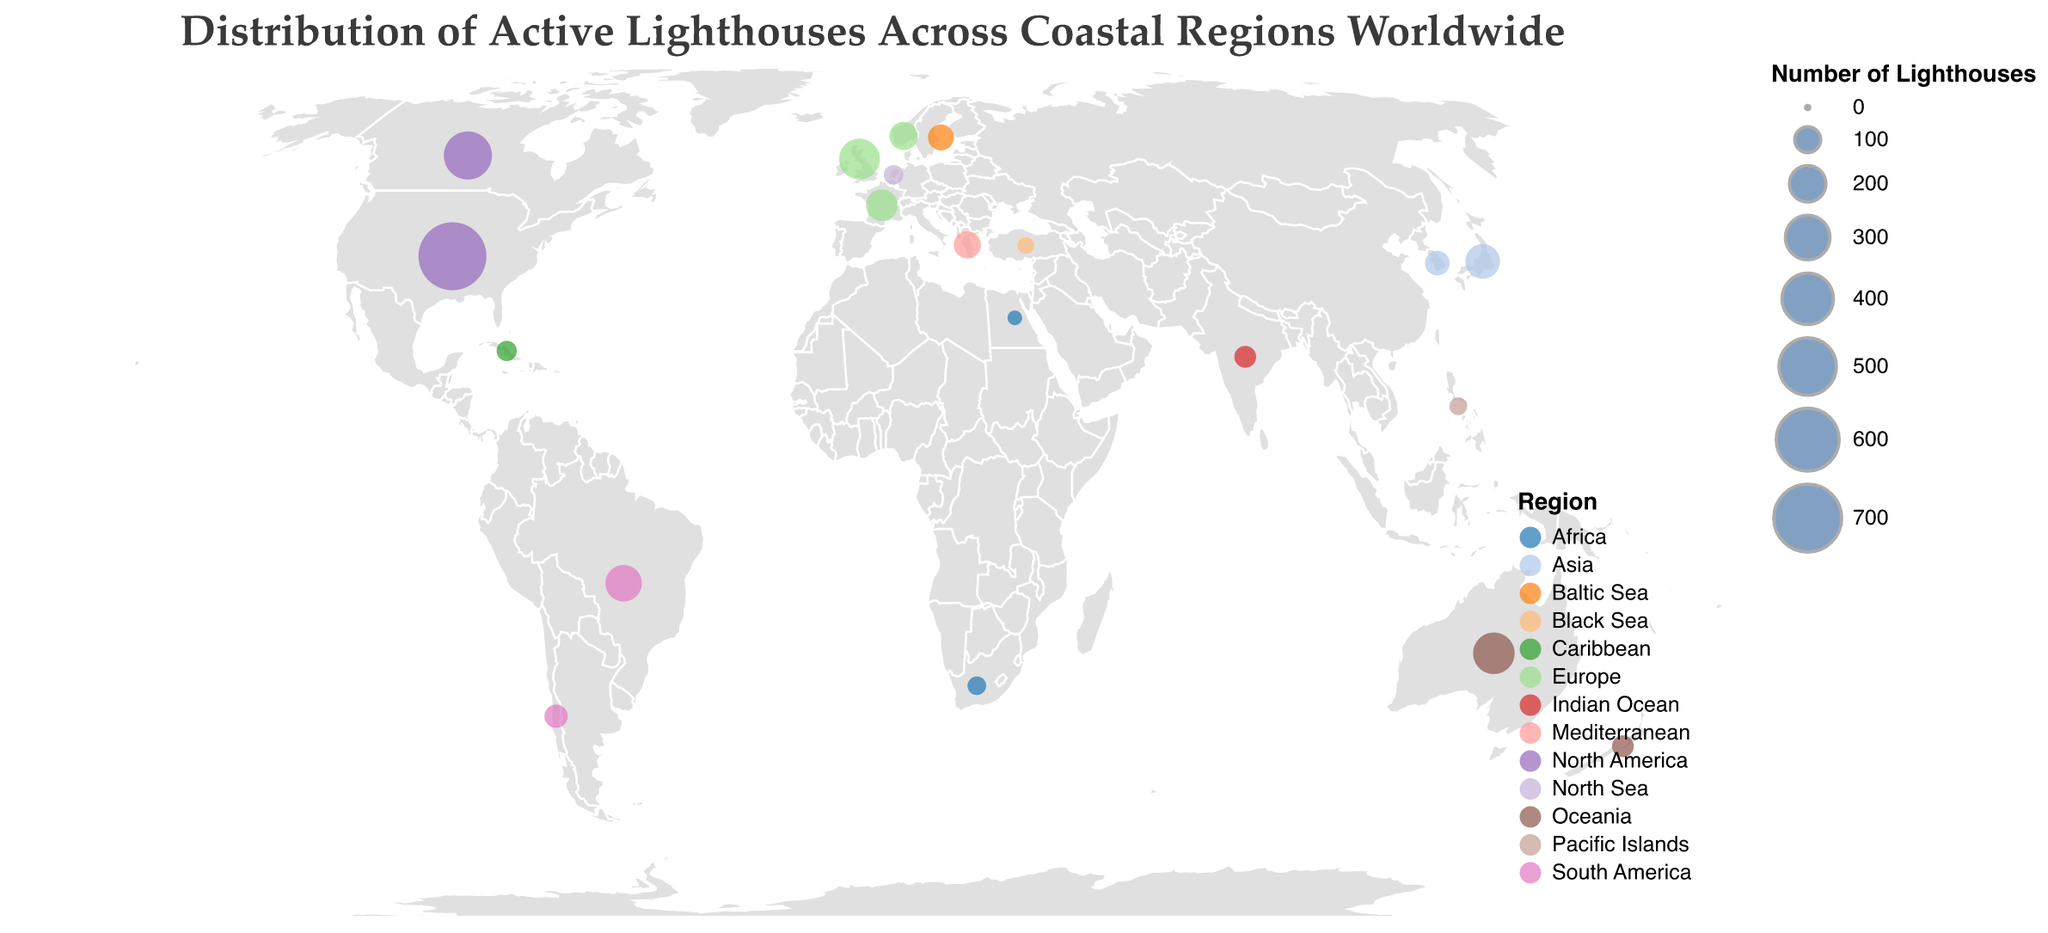What does the title of the figure convey? The title of the figure is "Distribution of Active Lighthouses Across Coastal Regions Worldwide." This indicates that the plot shows the geographical spread or density of active lighthouses in various coastal regions around the world.
Answer: Distribution of Active Lighthouses Across Coastal Regions Worldwide Which region is represented by the most colorful legend in the plot? The legend shows different colors for each region. The region with the most number of lighthouses, represented by the largest circles and most prominently shown, is North America.
Answer: North America How many lighthouses are there in total across Europe? To find the total number of lighthouses in Europe, sum the number of lighthouses in the United Kingdom (250), France (150), and Norway (120). This gives 250 + 150 + 120 = 520.
Answer: 520 Which country has the largest number of active lighthouses, and how many are there? The plot shows that the United States has the largest number of active lighthouses with a total of 700, indicated by the largest circle.
Answer: United States, 700 What’s the difference in the number of lighthouses between Japan and South Korea? To find this, subtract the number of lighthouses in South Korea (90) from Japan (180). The difference is 180 - 90 = 90.
Answer: 90 Among the listed countries, which one has the smallest number of active lighthouses and how many are there? The country with the smallest number of active lighthouses is Egypt, with a total of 30. This is indicated by the smallest circle in the plot.
Answer: Egypt, 30 How do the number of active lighthouses in Brazil compare to those in the rest of South America? Only Brazil and Chile are listed from South America. Brazil has 200 lighthouses, and Chile has 80. Brazil has more lighthouses than Chile.
Answer: Brazil has more How are the active lighthouses distributed in relation to geographical regions? The distribution shows varying densities of lighthouses across different regions. North America, Europe, and Oceania have higher densities, while Africa and the Caribbean have fewer. The distribution is visually conveyed by the sizes of the circles.
Answer: Higher densities in North America, Europe, and Oceania; fewer in Africa and the Caribbean Which country in the Caribbean has active lighthouses, and how many are there? According to the figure, Cuba in the Caribbean has 60 active lighthouses, as shown by the corresponding circle on the geographic plot.
Answer: Cuba, 60 What is the sum of active lighthouses in the Indian Ocean and Mediterranean regions? The sum of active lighthouses is calculated by adding the lighthouses in India (70) and Greece (110). This gives 70 + 110 = 180.
Answer: 180 